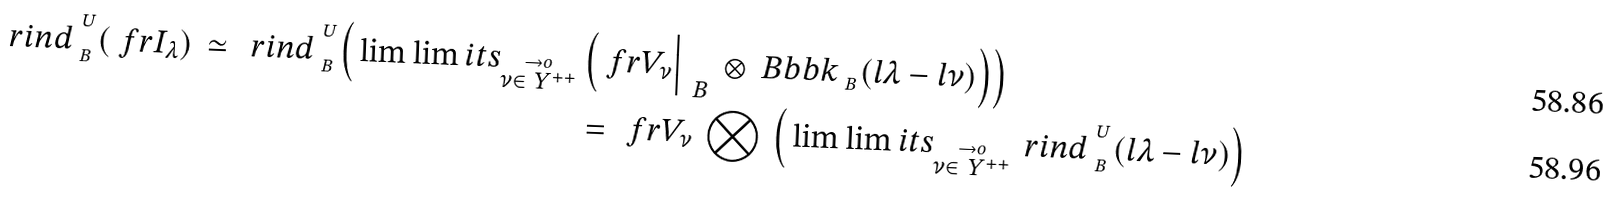<formula> <loc_0><loc_0><loc_500><loc_500>\ r i n d _ { _ { \ B } } ^ { ^ { \ U } } ( \ f r { I } _ { \lambda } ) \, \simeq \, \ r i n d _ { _ { \ B } } ^ { ^ { \ U } } \Big ( \lim \lim i t s _ { \stackrel { \to o } { \nu \in \ Y ^ { + + } } } & \, \Big ( \ f r { V _ { \nu } } \Big | _ { \, \ B } \, \otimes \ B b b k _ { _ { \ B } } ( { l } \lambda - { l } \nu ) \Big ) \Big ) \\ & = \, \ f r { V _ { \nu } } \, \bigotimes \, \Big ( \lim \lim i t s _ { \stackrel { \to o } { \nu \in \ Y ^ { + + } } } \, \ r i n d _ { _ { \ B } } ^ { ^ { \ U } } ( { l } \lambda - { l } \nu ) \Big )</formula> 